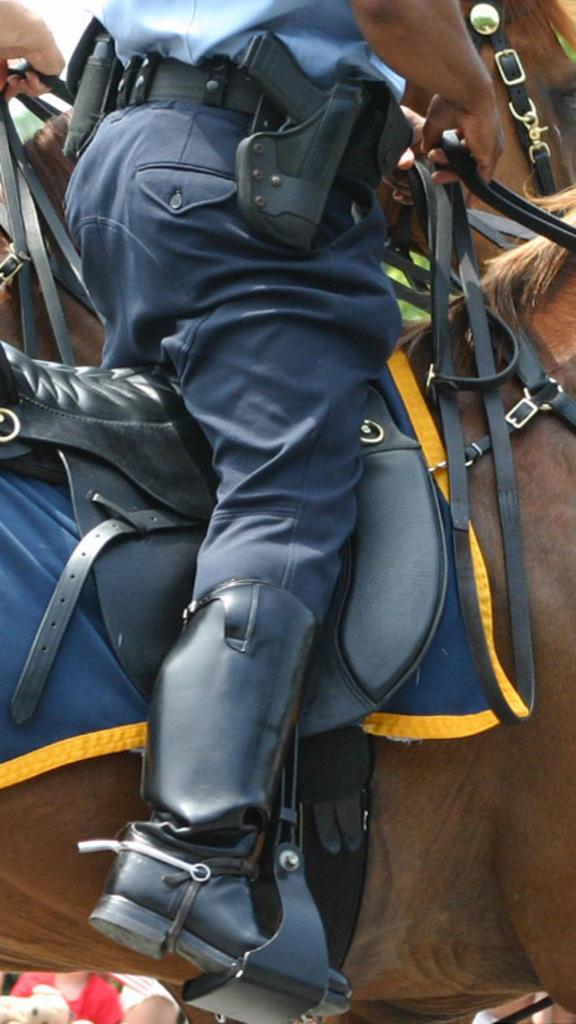What is the main subject of the image? There is a person in the image. What is the person doing in the image? The person is sitting on a horse. What is the person holding in the image? The person is holding a rope. What color is the person's shirt in the image? The person is wearing a blue shirt. What color are the person's pants in the image? The person is wearing blue pants. What is the person carrying in the image? The person is carrying a gun. What type of mist can be seen surrounding the station in the image? There is no mist or station present in the image; it features a person sitting on a horse. How much debt is the person carrying in the image? There is no indication of debt in the image; the person is carrying a gun. 